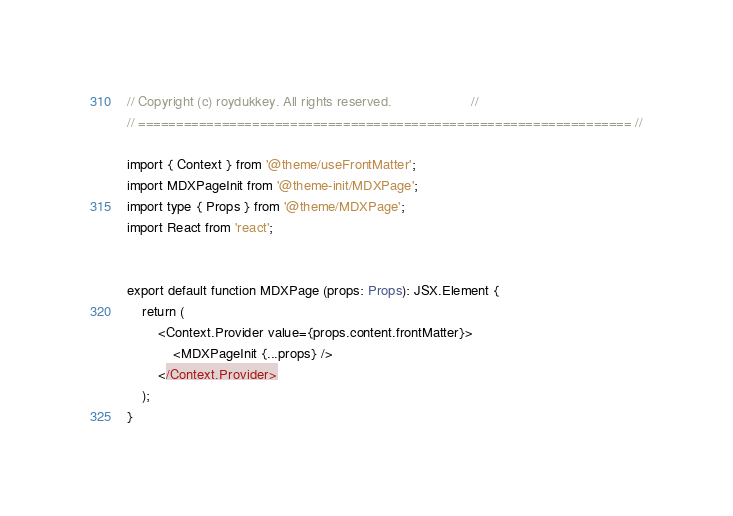Convert code to text. <code><loc_0><loc_0><loc_500><loc_500><_TypeScript_>// Copyright (c) roydukkey. All rights reserved.                     //
// ================================================================= //

import { Context } from '@theme/useFrontMatter';
import MDXPageInit from '@theme-init/MDXPage';
import type { Props } from '@theme/MDXPage';
import React from 'react';


export default function MDXPage (props: Props): JSX.Element {
	return (
		<Context.Provider value={props.content.frontMatter}>
			<MDXPageInit {...props} />
		</Context.Provider>
	);
}
</code> 